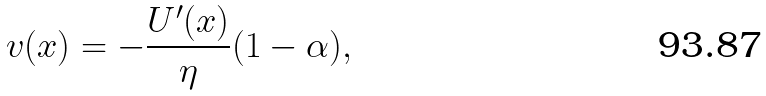Convert formula to latex. <formula><loc_0><loc_0><loc_500><loc_500>v ( x ) = - \frac { U ^ { \prime } ( x ) } { \eta } ( 1 - \alpha ) ,</formula> 